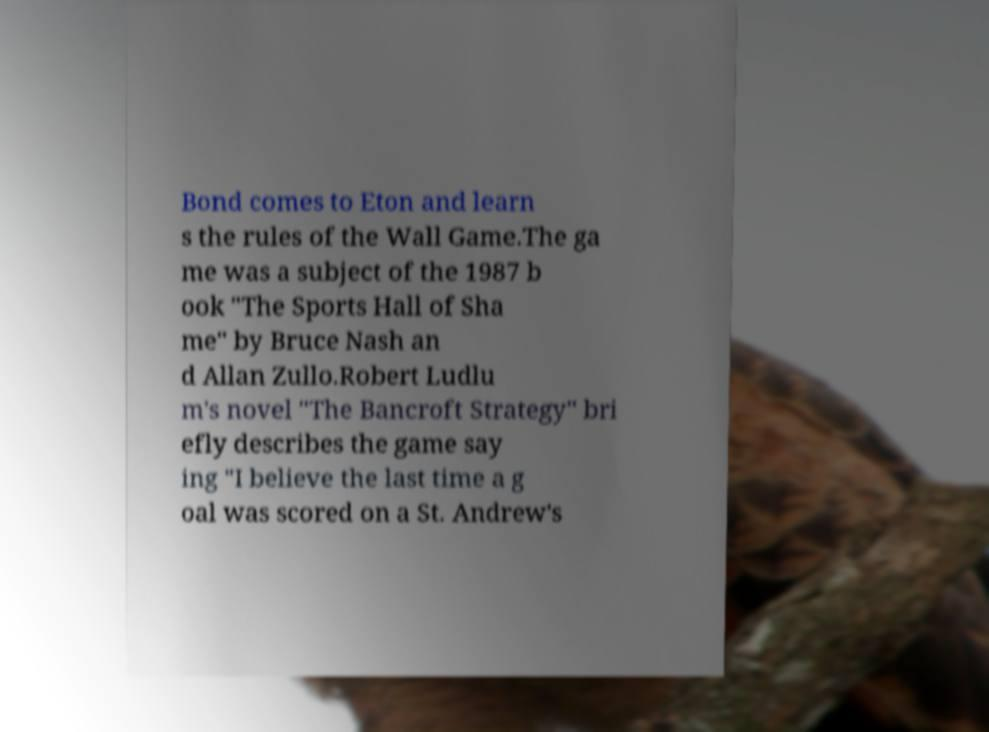Please identify and transcribe the text found in this image. Bond comes to Eton and learn s the rules of the Wall Game.The ga me was a subject of the 1987 b ook "The Sports Hall of Sha me" by Bruce Nash an d Allan Zullo.Robert Ludlu m's novel "The Bancroft Strategy" bri efly describes the game say ing "I believe the last time a g oal was scored on a St. Andrew's 